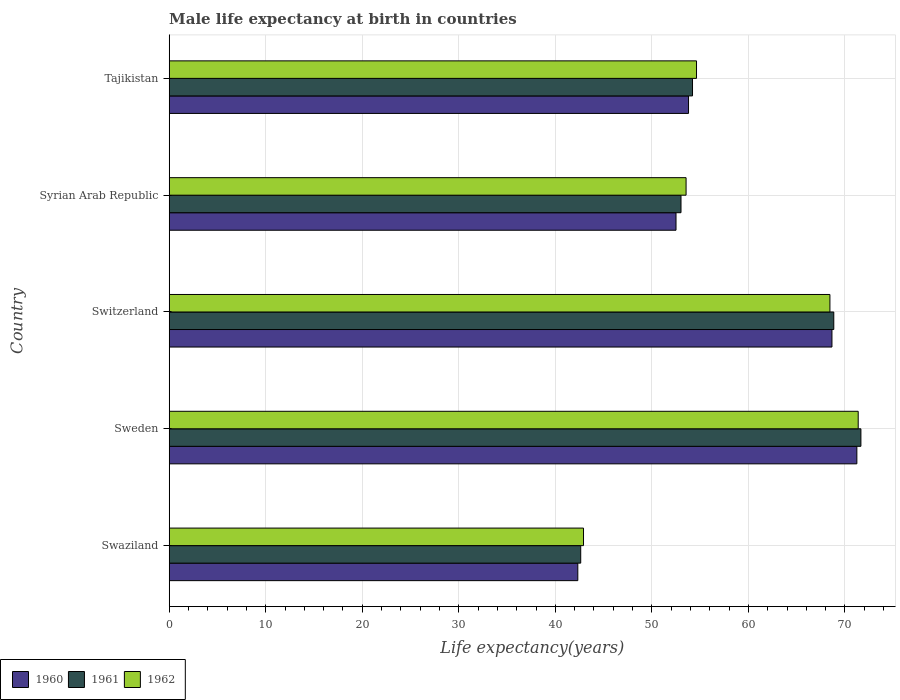How many groups of bars are there?
Offer a terse response. 5. Are the number of bars per tick equal to the number of legend labels?
Offer a very short reply. Yes. Are the number of bars on each tick of the Y-axis equal?
Make the answer very short. Yes. What is the male life expectancy at birth in 1961 in Syrian Arab Republic?
Your answer should be compact. 53.02. Across all countries, what is the maximum male life expectancy at birth in 1962?
Give a very brief answer. 71.37. Across all countries, what is the minimum male life expectancy at birth in 1961?
Offer a very short reply. 42.63. In which country was the male life expectancy at birth in 1961 maximum?
Keep it short and to the point. Sweden. In which country was the male life expectancy at birth in 1961 minimum?
Offer a very short reply. Swaziland. What is the total male life expectancy at birth in 1962 in the graph?
Ensure brevity in your answer.  290.89. What is the difference between the male life expectancy at birth in 1962 in Syrian Arab Republic and that in Tajikistan?
Your response must be concise. -1.08. What is the difference between the male life expectancy at birth in 1960 in Syrian Arab Republic and the male life expectancy at birth in 1961 in Sweden?
Make the answer very short. -19.15. What is the average male life expectancy at birth in 1961 per country?
Give a very brief answer. 58.07. What is the difference between the male life expectancy at birth in 1962 and male life expectancy at birth in 1960 in Tajikistan?
Provide a short and direct response. 0.83. In how many countries, is the male life expectancy at birth in 1962 greater than 10 years?
Give a very brief answer. 5. What is the ratio of the male life expectancy at birth in 1961 in Sweden to that in Switzerland?
Make the answer very short. 1.04. Is the male life expectancy at birth in 1962 in Syrian Arab Republic less than that in Tajikistan?
Provide a succinct answer. Yes. Is the difference between the male life expectancy at birth in 1962 in Swaziland and Syrian Arab Republic greater than the difference between the male life expectancy at birth in 1960 in Swaziland and Syrian Arab Republic?
Offer a terse response. No. What is the difference between the highest and the second highest male life expectancy at birth in 1962?
Offer a very short reply. 2.93. What is the difference between the highest and the lowest male life expectancy at birth in 1962?
Give a very brief answer. 28.45. Is the sum of the male life expectancy at birth in 1960 in Syrian Arab Republic and Tajikistan greater than the maximum male life expectancy at birth in 1961 across all countries?
Provide a short and direct response. Yes. What does the 1st bar from the top in Sweden represents?
Your response must be concise. 1962. Is it the case that in every country, the sum of the male life expectancy at birth in 1961 and male life expectancy at birth in 1962 is greater than the male life expectancy at birth in 1960?
Ensure brevity in your answer.  Yes. How many bars are there?
Make the answer very short. 15. How many countries are there in the graph?
Offer a very short reply. 5. What is the difference between two consecutive major ticks on the X-axis?
Your response must be concise. 10. Does the graph contain any zero values?
Offer a terse response. No. How many legend labels are there?
Ensure brevity in your answer.  3. What is the title of the graph?
Provide a short and direct response. Male life expectancy at birth in countries. What is the label or title of the X-axis?
Your response must be concise. Life expectancy(years). What is the label or title of the Y-axis?
Your answer should be compact. Country. What is the Life expectancy(years) in 1960 in Swaziland?
Provide a succinct answer. 42.33. What is the Life expectancy(years) of 1961 in Swaziland?
Keep it short and to the point. 42.63. What is the Life expectancy(years) in 1962 in Swaziland?
Your response must be concise. 42.92. What is the Life expectancy(years) in 1960 in Sweden?
Keep it short and to the point. 71.23. What is the Life expectancy(years) in 1961 in Sweden?
Keep it short and to the point. 71.65. What is the Life expectancy(years) in 1962 in Sweden?
Make the answer very short. 71.37. What is the Life expectancy(years) in 1960 in Switzerland?
Offer a very short reply. 68.65. What is the Life expectancy(years) in 1961 in Switzerland?
Ensure brevity in your answer.  68.84. What is the Life expectancy(years) of 1962 in Switzerland?
Offer a terse response. 68.44. What is the Life expectancy(years) of 1960 in Syrian Arab Republic?
Your response must be concise. 52.5. What is the Life expectancy(years) of 1961 in Syrian Arab Republic?
Make the answer very short. 53.02. What is the Life expectancy(years) in 1962 in Syrian Arab Republic?
Provide a short and direct response. 53.54. What is the Life expectancy(years) in 1960 in Tajikistan?
Give a very brief answer. 53.8. What is the Life expectancy(years) of 1961 in Tajikistan?
Offer a terse response. 54.21. What is the Life expectancy(years) in 1962 in Tajikistan?
Make the answer very short. 54.62. Across all countries, what is the maximum Life expectancy(years) of 1960?
Keep it short and to the point. 71.23. Across all countries, what is the maximum Life expectancy(years) of 1961?
Your answer should be very brief. 71.65. Across all countries, what is the maximum Life expectancy(years) of 1962?
Keep it short and to the point. 71.37. Across all countries, what is the minimum Life expectancy(years) in 1960?
Your response must be concise. 42.33. Across all countries, what is the minimum Life expectancy(years) in 1961?
Offer a very short reply. 42.63. Across all countries, what is the minimum Life expectancy(years) of 1962?
Make the answer very short. 42.92. What is the total Life expectancy(years) in 1960 in the graph?
Offer a terse response. 288.5. What is the total Life expectancy(years) of 1961 in the graph?
Offer a very short reply. 290.34. What is the total Life expectancy(years) in 1962 in the graph?
Your response must be concise. 290.89. What is the difference between the Life expectancy(years) of 1960 in Swaziland and that in Sweden?
Your response must be concise. -28.91. What is the difference between the Life expectancy(years) in 1961 in Swaziland and that in Sweden?
Offer a very short reply. -29.02. What is the difference between the Life expectancy(years) of 1962 in Swaziland and that in Sweden?
Provide a short and direct response. -28.45. What is the difference between the Life expectancy(years) of 1960 in Swaziland and that in Switzerland?
Make the answer very short. -26.32. What is the difference between the Life expectancy(years) of 1961 in Swaziland and that in Switzerland?
Offer a terse response. -26.21. What is the difference between the Life expectancy(years) in 1962 in Swaziland and that in Switzerland?
Offer a terse response. -25.52. What is the difference between the Life expectancy(years) of 1960 in Swaziland and that in Syrian Arab Republic?
Give a very brief answer. -10.17. What is the difference between the Life expectancy(years) in 1961 in Swaziland and that in Syrian Arab Republic?
Provide a succinct answer. -10.39. What is the difference between the Life expectancy(years) of 1962 in Swaziland and that in Syrian Arab Republic?
Make the answer very short. -10.62. What is the difference between the Life expectancy(years) of 1960 in Swaziland and that in Tajikistan?
Offer a very short reply. -11.47. What is the difference between the Life expectancy(years) of 1961 in Swaziland and that in Tajikistan?
Offer a very short reply. -11.58. What is the difference between the Life expectancy(years) of 1962 in Swaziland and that in Tajikistan?
Provide a succinct answer. -11.71. What is the difference between the Life expectancy(years) of 1960 in Sweden and that in Switzerland?
Your response must be concise. 2.58. What is the difference between the Life expectancy(years) of 1961 in Sweden and that in Switzerland?
Provide a succinct answer. 2.81. What is the difference between the Life expectancy(years) of 1962 in Sweden and that in Switzerland?
Provide a short and direct response. 2.93. What is the difference between the Life expectancy(years) in 1960 in Sweden and that in Syrian Arab Republic?
Provide a succinct answer. 18.73. What is the difference between the Life expectancy(years) in 1961 in Sweden and that in Syrian Arab Republic?
Ensure brevity in your answer.  18.64. What is the difference between the Life expectancy(years) of 1962 in Sweden and that in Syrian Arab Republic?
Give a very brief answer. 17.83. What is the difference between the Life expectancy(years) of 1960 in Sweden and that in Tajikistan?
Your answer should be very brief. 17.43. What is the difference between the Life expectancy(years) in 1961 in Sweden and that in Tajikistan?
Your answer should be compact. 17.44. What is the difference between the Life expectancy(years) of 1962 in Sweden and that in Tajikistan?
Your answer should be very brief. 16.75. What is the difference between the Life expectancy(years) in 1960 in Switzerland and that in Syrian Arab Republic?
Your answer should be very brief. 16.15. What is the difference between the Life expectancy(years) of 1961 in Switzerland and that in Syrian Arab Republic?
Offer a terse response. 15.82. What is the difference between the Life expectancy(years) of 1962 in Switzerland and that in Syrian Arab Republic?
Your answer should be compact. 14.9. What is the difference between the Life expectancy(years) of 1960 in Switzerland and that in Tajikistan?
Give a very brief answer. 14.86. What is the difference between the Life expectancy(years) of 1961 in Switzerland and that in Tajikistan?
Provide a succinct answer. 14.63. What is the difference between the Life expectancy(years) in 1962 in Switzerland and that in Tajikistan?
Provide a short and direct response. 13.82. What is the difference between the Life expectancy(years) of 1960 in Syrian Arab Republic and that in Tajikistan?
Provide a short and direct response. -1.3. What is the difference between the Life expectancy(years) of 1961 in Syrian Arab Republic and that in Tajikistan?
Provide a succinct answer. -1.19. What is the difference between the Life expectancy(years) in 1962 in Syrian Arab Republic and that in Tajikistan?
Offer a terse response. -1.08. What is the difference between the Life expectancy(years) in 1960 in Swaziland and the Life expectancy(years) in 1961 in Sweden?
Your answer should be compact. -29.32. What is the difference between the Life expectancy(years) in 1960 in Swaziland and the Life expectancy(years) in 1962 in Sweden?
Give a very brief answer. -29.05. What is the difference between the Life expectancy(years) in 1961 in Swaziland and the Life expectancy(years) in 1962 in Sweden?
Make the answer very short. -28.74. What is the difference between the Life expectancy(years) in 1960 in Swaziland and the Life expectancy(years) in 1961 in Switzerland?
Your answer should be compact. -26.52. What is the difference between the Life expectancy(years) in 1960 in Swaziland and the Life expectancy(years) in 1962 in Switzerland?
Keep it short and to the point. -26.11. What is the difference between the Life expectancy(years) in 1961 in Swaziland and the Life expectancy(years) in 1962 in Switzerland?
Offer a very short reply. -25.81. What is the difference between the Life expectancy(years) in 1960 in Swaziland and the Life expectancy(years) in 1961 in Syrian Arab Republic?
Keep it short and to the point. -10.69. What is the difference between the Life expectancy(years) in 1960 in Swaziland and the Life expectancy(years) in 1962 in Syrian Arab Republic?
Provide a succinct answer. -11.21. What is the difference between the Life expectancy(years) in 1961 in Swaziland and the Life expectancy(years) in 1962 in Syrian Arab Republic?
Ensure brevity in your answer.  -10.91. What is the difference between the Life expectancy(years) in 1960 in Swaziland and the Life expectancy(years) in 1961 in Tajikistan?
Keep it short and to the point. -11.88. What is the difference between the Life expectancy(years) of 1960 in Swaziland and the Life expectancy(years) of 1962 in Tajikistan?
Give a very brief answer. -12.3. What is the difference between the Life expectancy(years) in 1961 in Swaziland and the Life expectancy(years) in 1962 in Tajikistan?
Give a very brief answer. -11.99. What is the difference between the Life expectancy(years) in 1960 in Sweden and the Life expectancy(years) in 1961 in Switzerland?
Give a very brief answer. 2.39. What is the difference between the Life expectancy(years) in 1960 in Sweden and the Life expectancy(years) in 1962 in Switzerland?
Provide a short and direct response. 2.79. What is the difference between the Life expectancy(years) of 1961 in Sweden and the Life expectancy(years) of 1962 in Switzerland?
Provide a succinct answer. 3.21. What is the difference between the Life expectancy(years) of 1960 in Sweden and the Life expectancy(years) of 1961 in Syrian Arab Republic?
Keep it short and to the point. 18.21. What is the difference between the Life expectancy(years) in 1960 in Sweden and the Life expectancy(years) in 1962 in Syrian Arab Republic?
Provide a short and direct response. 17.69. What is the difference between the Life expectancy(years) of 1961 in Sweden and the Life expectancy(years) of 1962 in Syrian Arab Republic?
Give a very brief answer. 18.11. What is the difference between the Life expectancy(years) of 1960 in Sweden and the Life expectancy(years) of 1961 in Tajikistan?
Keep it short and to the point. 17.02. What is the difference between the Life expectancy(years) in 1960 in Sweden and the Life expectancy(years) in 1962 in Tajikistan?
Your response must be concise. 16.61. What is the difference between the Life expectancy(years) in 1961 in Sweden and the Life expectancy(years) in 1962 in Tajikistan?
Make the answer very short. 17.03. What is the difference between the Life expectancy(years) of 1960 in Switzerland and the Life expectancy(years) of 1961 in Syrian Arab Republic?
Offer a very short reply. 15.63. What is the difference between the Life expectancy(years) of 1960 in Switzerland and the Life expectancy(years) of 1962 in Syrian Arab Republic?
Your response must be concise. 15.11. What is the difference between the Life expectancy(years) in 1961 in Switzerland and the Life expectancy(years) in 1962 in Syrian Arab Republic?
Ensure brevity in your answer.  15.3. What is the difference between the Life expectancy(years) in 1960 in Switzerland and the Life expectancy(years) in 1961 in Tajikistan?
Offer a terse response. 14.44. What is the difference between the Life expectancy(years) in 1960 in Switzerland and the Life expectancy(years) in 1962 in Tajikistan?
Your response must be concise. 14.03. What is the difference between the Life expectancy(years) in 1961 in Switzerland and the Life expectancy(years) in 1962 in Tajikistan?
Offer a terse response. 14.22. What is the difference between the Life expectancy(years) of 1960 in Syrian Arab Republic and the Life expectancy(years) of 1961 in Tajikistan?
Provide a succinct answer. -1.71. What is the difference between the Life expectancy(years) in 1960 in Syrian Arab Republic and the Life expectancy(years) in 1962 in Tajikistan?
Provide a succinct answer. -2.12. What is the difference between the Life expectancy(years) of 1961 in Syrian Arab Republic and the Life expectancy(years) of 1962 in Tajikistan?
Your answer should be very brief. -1.61. What is the average Life expectancy(years) in 1960 per country?
Offer a terse response. 57.7. What is the average Life expectancy(years) of 1961 per country?
Your response must be concise. 58.07. What is the average Life expectancy(years) of 1962 per country?
Keep it short and to the point. 58.18. What is the difference between the Life expectancy(years) of 1960 and Life expectancy(years) of 1961 in Swaziland?
Your answer should be very brief. -0.3. What is the difference between the Life expectancy(years) of 1960 and Life expectancy(years) of 1962 in Swaziland?
Your response must be concise. -0.59. What is the difference between the Life expectancy(years) of 1961 and Life expectancy(years) of 1962 in Swaziland?
Give a very brief answer. -0.29. What is the difference between the Life expectancy(years) of 1960 and Life expectancy(years) of 1961 in Sweden?
Ensure brevity in your answer.  -0.42. What is the difference between the Life expectancy(years) in 1960 and Life expectancy(years) in 1962 in Sweden?
Your answer should be very brief. -0.14. What is the difference between the Life expectancy(years) of 1961 and Life expectancy(years) of 1962 in Sweden?
Your answer should be very brief. 0.28. What is the difference between the Life expectancy(years) of 1960 and Life expectancy(years) of 1961 in Switzerland?
Ensure brevity in your answer.  -0.19. What is the difference between the Life expectancy(years) in 1960 and Life expectancy(years) in 1962 in Switzerland?
Give a very brief answer. 0.21. What is the difference between the Life expectancy(years) in 1960 and Life expectancy(years) in 1961 in Syrian Arab Republic?
Keep it short and to the point. -0.52. What is the difference between the Life expectancy(years) of 1960 and Life expectancy(years) of 1962 in Syrian Arab Republic?
Provide a short and direct response. -1.04. What is the difference between the Life expectancy(years) of 1961 and Life expectancy(years) of 1962 in Syrian Arab Republic?
Offer a terse response. -0.53. What is the difference between the Life expectancy(years) in 1960 and Life expectancy(years) in 1961 in Tajikistan?
Provide a succinct answer. -0.41. What is the difference between the Life expectancy(years) in 1960 and Life expectancy(years) in 1962 in Tajikistan?
Make the answer very short. -0.83. What is the difference between the Life expectancy(years) in 1961 and Life expectancy(years) in 1962 in Tajikistan?
Your answer should be compact. -0.41. What is the ratio of the Life expectancy(years) in 1960 in Swaziland to that in Sweden?
Your answer should be very brief. 0.59. What is the ratio of the Life expectancy(years) in 1961 in Swaziland to that in Sweden?
Your answer should be compact. 0.59. What is the ratio of the Life expectancy(years) of 1962 in Swaziland to that in Sweden?
Your answer should be very brief. 0.6. What is the ratio of the Life expectancy(years) of 1960 in Swaziland to that in Switzerland?
Provide a short and direct response. 0.62. What is the ratio of the Life expectancy(years) of 1961 in Swaziland to that in Switzerland?
Keep it short and to the point. 0.62. What is the ratio of the Life expectancy(years) of 1962 in Swaziland to that in Switzerland?
Give a very brief answer. 0.63. What is the ratio of the Life expectancy(years) in 1960 in Swaziland to that in Syrian Arab Republic?
Keep it short and to the point. 0.81. What is the ratio of the Life expectancy(years) of 1961 in Swaziland to that in Syrian Arab Republic?
Your response must be concise. 0.8. What is the ratio of the Life expectancy(years) of 1962 in Swaziland to that in Syrian Arab Republic?
Ensure brevity in your answer.  0.8. What is the ratio of the Life expectancy(years) of 1960 in Swaziland to that in Tajikistan?
Offer a very short reply. 0.79. What is the ratio of the Life expectancy(years) of 1961 in Swaziland to that in Tajikistan?
Keep it short and to the point. 0.79. What is the ratio of the Life expectancy(years) in 1962 in Swaziland to that in Tajikistan?
Provide a short and direct response. 0.79. What is the ratio of the Life expectancy(years) of 1960 in Sweden to that in Switzerland?
Your answer should be compact. 1.04. What is the ratio of the Life expectancy(years) of 1961 in Sweden to that in Switzerland?
Give a very brief answer. 1.04. What is the ratio of the Life expectancy(years) in 1962 in Sweden to that in Switzerland?
Provide a succinct answer. 1.04. What is the ratio of the Life expectancy(years) in 1960 in Sweden to that in Syrian Arab Republic?
Your answer should be very brief. 1.36. What is the ratio of the Life expectancy(years) of 1961 in Sweden to that in Syrian Arab Republic?
Offer a terse response. 1.35. What is the ratio of the Life expectancy(years) of 1962 in Sweden to that in Syrian Arab Republic?
Your answer should be compact. 1.33. What is the ratio of the Life expectancy(years) of 1960 in Sweden to that in Tajikistan?
Keep it short and to the point. 1.32. What is the ratio of the Life expectancy(years) in 1961 in Sweden to that in Tajikistan?
Offer a very short reply. 1.32. What is the ratio of the Life expectancy(years) of 1962 in Sweden to that in Tajikistan?
Provide a short and direct response. 1.31. What is the ratio of the Life expectancy(years) of 1960 in Switzerland to that in Syrian Arab Republic?
Offer a very short reply. 1.31. What is the ratio of the Life expectancy(years) in 1961 in Switzerland to that in Syrian Arab Republic?
Your answer should be compact. 1.3. What is the ratio of the Life expectancy(years) of 1962 in Switzerland to that in Syrian Arab Republic?
Keep it short and to the point. 1.28. What is the ratio of the Life expectancy(years) in 1960 in Switzerland to that in Tajikistan?
Your answer should be compact. 1.28. What is the ratio of the Life expectancy(years) in 1961 in Switzerland to that in Tajikistan?
Make the answer very short. 1.27. What is the ratio of the Life expectancy(years) of 1962 in Switzerland to that in Tajikistan?
Keep it short and to the point. 1.25. What is the ratio of the Life expectancy(years) in 1960 in Syrian Arab Republic to that in Tajikistan?
Your answer should be compact. 0.98. What is the ratio of the Life expectancy(years) of 1962 in Syrian Arab Republic to that in Tajikistan?
Give a very brief answer. 0.98. What is the difference between the highest and the second highest Life expectancy(years) of 1960?
Your answer should be compact. 2.58. What is the difference between the highest and the second highest Life expectancy(years) in 1961?
Your response must be concise. 2.81. What is the difference between the highest and the second highest Life expectancy(years) of 1962?
Provide a succinct answer. 2.93. What is the difference between the highest and the lowest Life expectancy(years) in 1960?
Offer a very short reply. 28.91. What is the difference between the highest and the lowest Life expectancy(years) of 1961?
Make the answer very short. 29.02. What is the difference between the highest and the lowest Life expectancy(years) of 1962?
Provide a succinct answer. 28.45. 